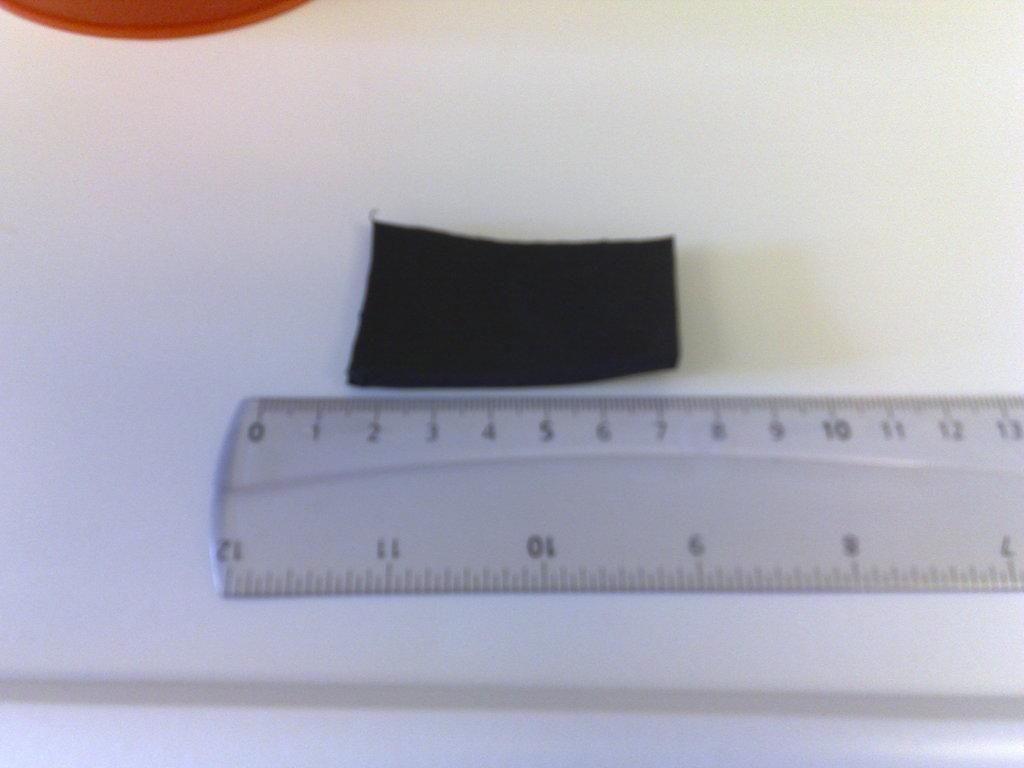Provide a one-sentence caption for the provided image. black rectangle that is about 6 cm next to a clear ruler. 